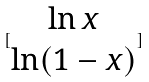Convert formula to latex. <formula><loc_0><loc_0><loc_500><loc_500>[ \begin{matrix} \ln x \\ \ln ( 1 - x ) \end{matrix} ]</formula> 